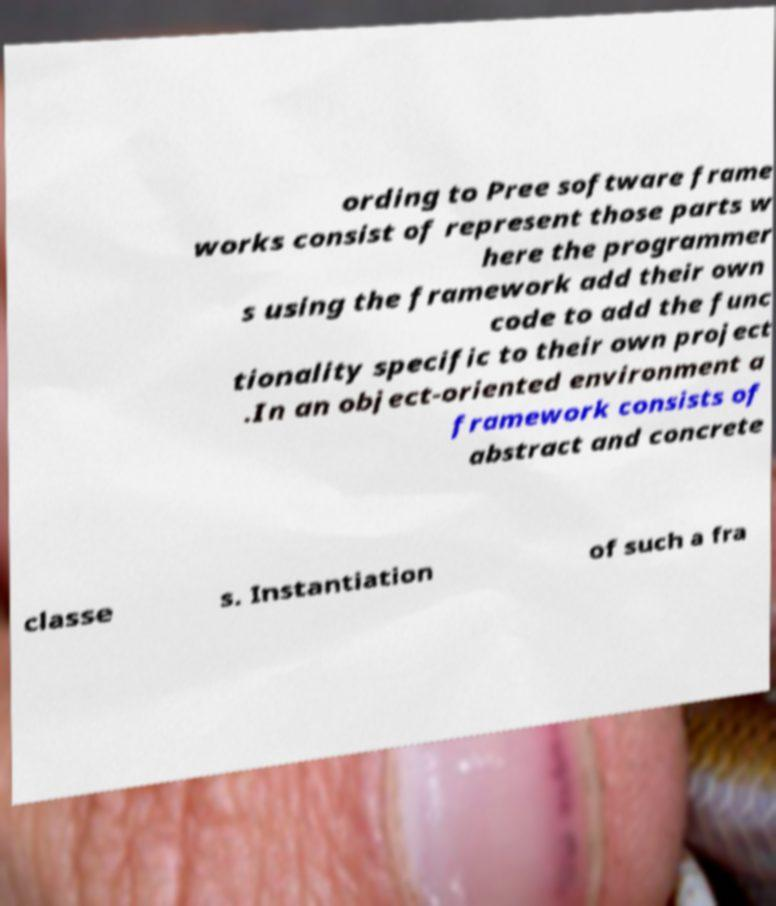Please identify and transcribe the text found in this image. ording to Pree software frame works consist of represent those parts w here the programmer s using the framework add their own code to add the func tionality specific to their own project .In an object-oriented environment a framework consists of abstract and concrete classe s. Instantiation of such a fra 